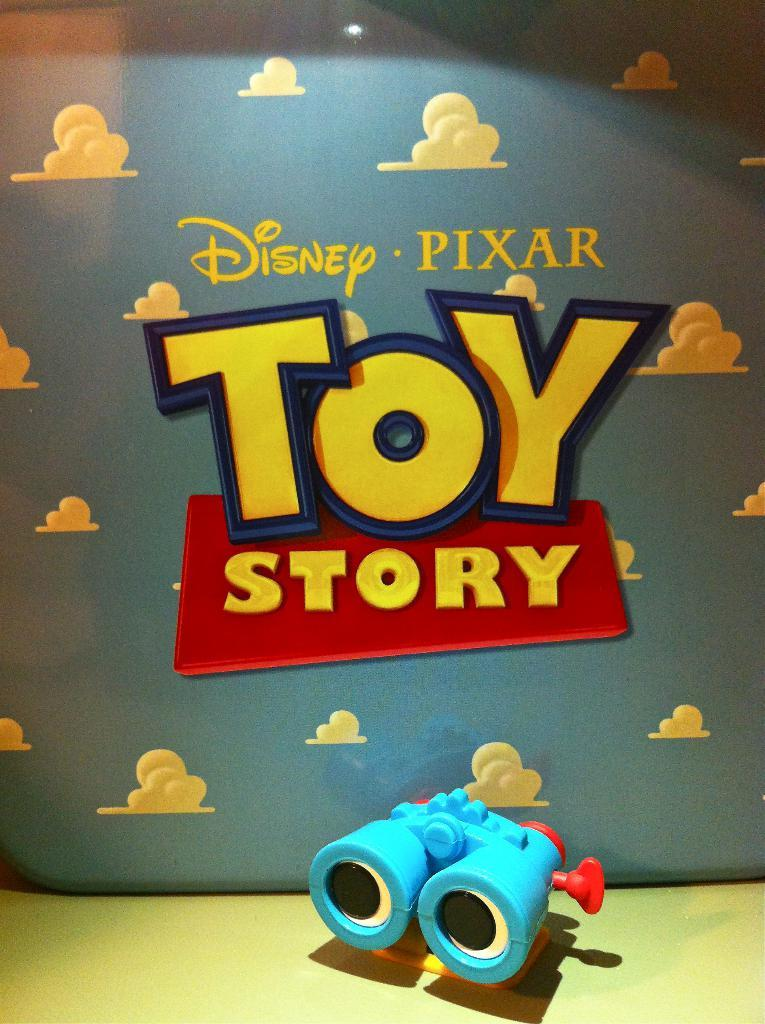<image>
Offer a succinct explanation of the picture presented. The movie Toy Story with a pair of binoculars below the title 